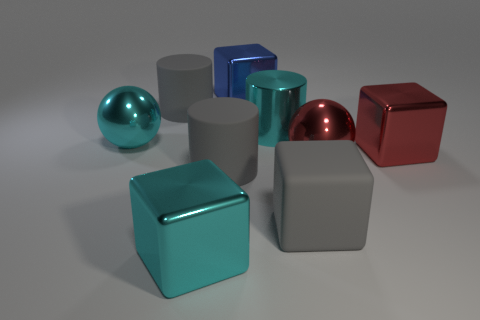Does the shiny cylinder have the same color as the big matte cylinder left of the large cyan shiny block?
Keep it short and to the point. No. What color is the matte cube that is the same size as the blue metal cube?
Provide a short and direct response. Gray. Are there any tiny rubber objects that have the same shape as the big blue thing?
Your answer should be compact. No. Is the number of blue metallic cylinders less than the number of big cyan metallic balls?
Provide a succinct answer. Yes. There is a sphere that is to the right of the gray cube; what is its color?
Your answer should be compact. Red. What shape is the big gray matte thing that is on the left side of the shiny object that is in front of the red metallic sphere?
Offer a very short reply. Cylinder. Are the cyan cube and the sphere that is on the left side of the rubber cube made of the same material?
Provide a succinct answer. Yes. What number of shiny cubes have the same size as the cyan metal cylinder?
Provide a short and direct response. 3. Are there fewer blue metallic things that are to the right of the metallic cylinder than large blue metal objects?
Keep it short and to the point. Yes. What number of cubes are behind the big cyan cylinder?
Give a very brief answer. 1. 